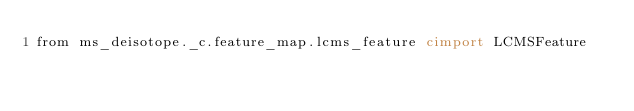Convert code to text. <code><loc_0><loc_0><loc_500><loc_500><_Cython_>from ms_deisotope._c.feature_map.lcms_feature cimport LCMSFeature</code> 